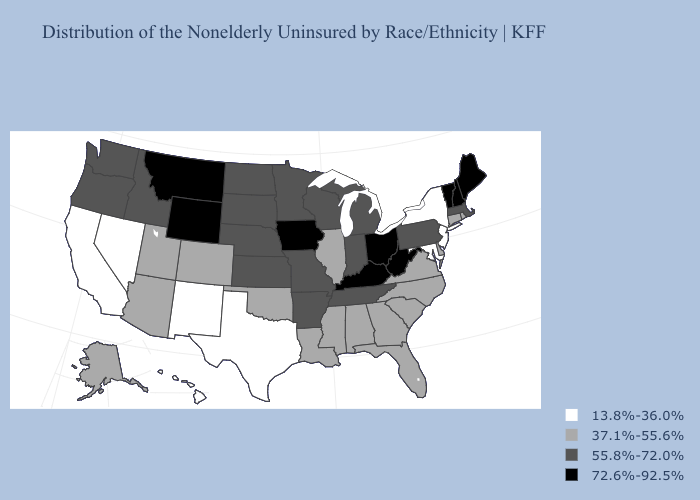What is the value of Nebraska?
Write a very short answer. 55.8%-72.0%. What is the value of Minnesota?
Answer briefly. 55.8%-72.0%. Name the states that have a value in the range 72.6%-92.5%?
Short answer required. Iowa, Kentucky, Maine, Montana, New Hampshire, Ohio, Vermont, West Virginia, Wyoming. Does Maryland have the lowest value in the USA?
Give a very brief answer. Yes. What is the value of West Virginia?
Answer briefly. 72.6%-92.5%. How many symbols are there in the legend?
Keep it brief. 4. Name the states that have a value in the range 55.8%-72.0%?
Quick response, please. Arkansas, Idaho, Indiana, Kansas, Massachusetts, Michigan, Minnesota, Missouri, Nebraska, North Dakota, Oregon, Pennsylvania, South Dakota, Tennessee, Washington, Wisconsin. What is the highest value in the USA?
Be succinct. 72.6%-92.5%. What is the lowest value in the South?
Be succinct. 13.8%-36.0%. What is the highest value in the West ?
Write a very short answer. 72.6%-92.5%. Name the states that have a value in the range 72.6%-92.5%?
Give a very brief answer. Iowa, Kentucky, Maine, Montana, New Hampshire, Ohio, Vermont, West Virginia, Wyoming. Which states have the lowest value in the USA?
Give a very brief answer. California, Hawaii, Maryland, Nevada, New Jersey, New Mexico, New York, Texas. Which states hav the highest value in the Northeast?
Answer briefly. Maine, New Hampshire, Vermont. Does New York have the same value as Maryland?
Quick response, please. Yes. Among the states that border Delaware , which have the highest value?
Keep it brief. Pennsylvania. 